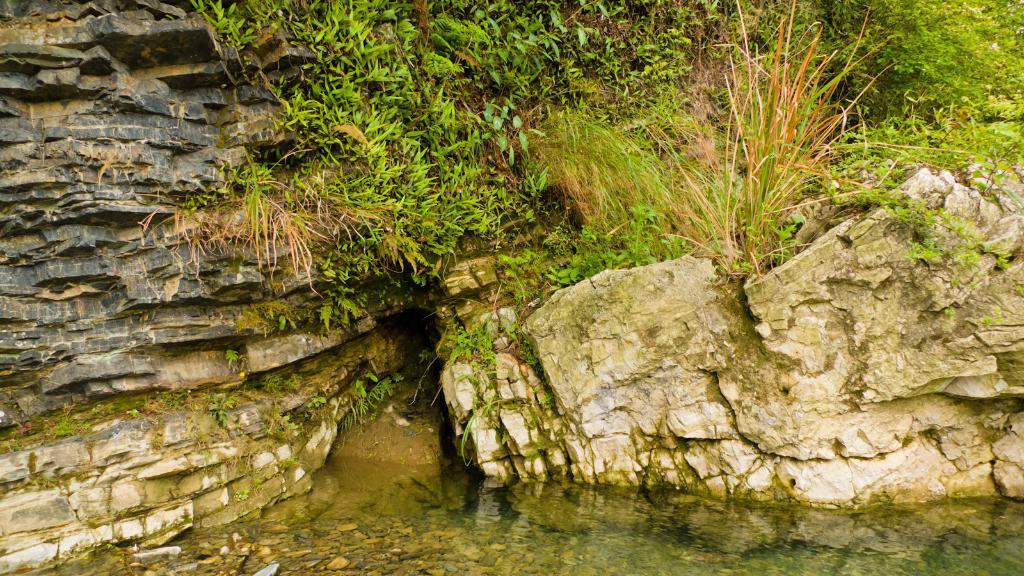What type of living organisms can be seen in the image? Plants can be seen in the image. What type of inanimate objects are present in the image? Rocks and stones are present in the image. What is visible at the bottom of the image? Water is visible at the bottom of the image. What type of record can be seen playing in the image? There is no record present in the image. What word is written on the rocks in the image? There are no words written on the rocks in the image. 